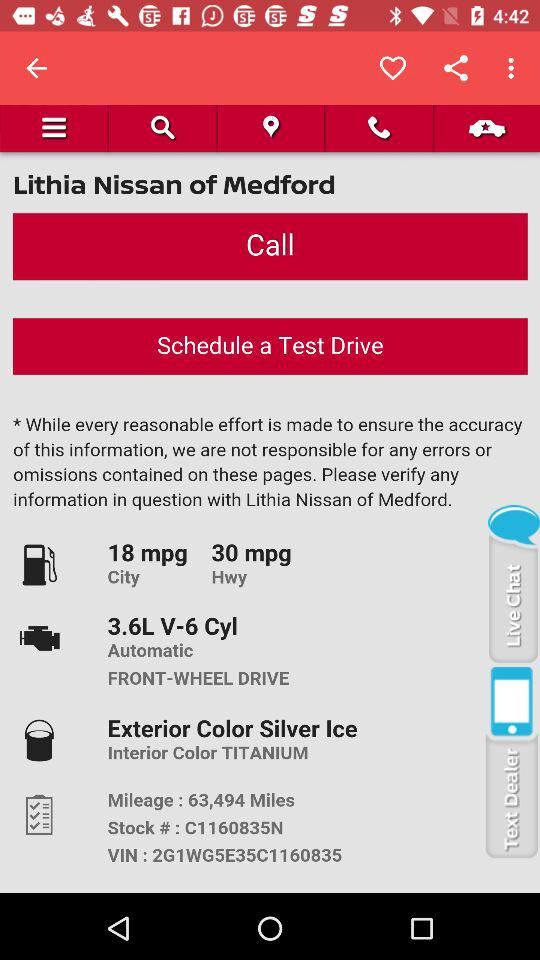What is the mileage? The mileage is 63,494 miles. 